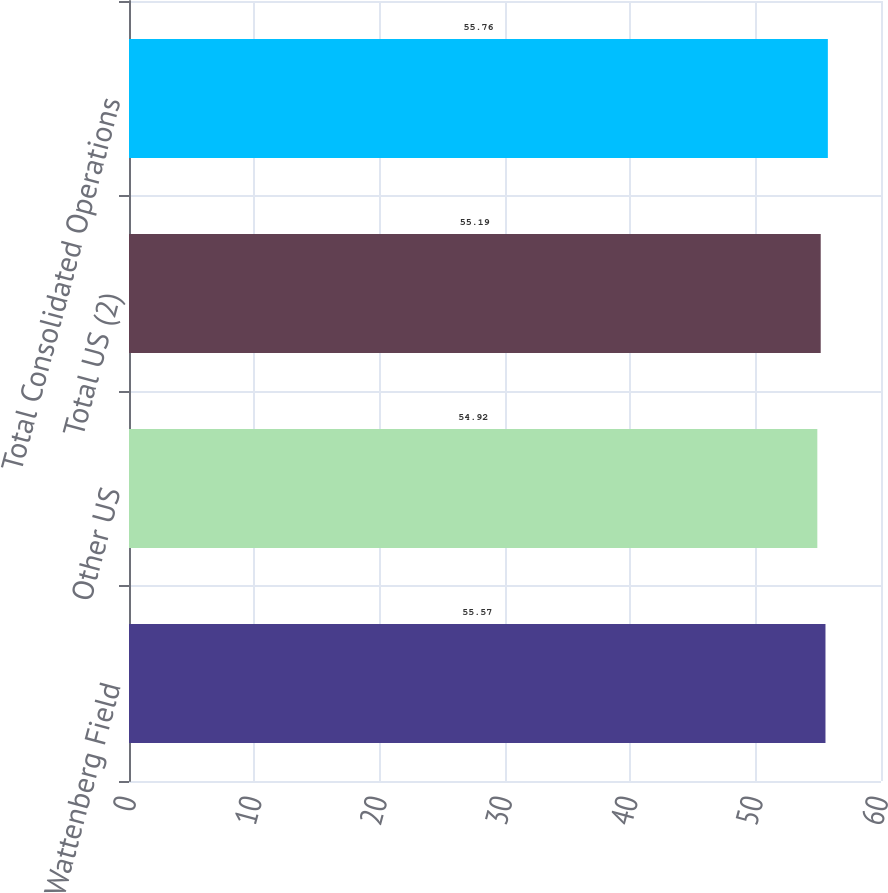Convert chart. <chart><loc_0><loc_0><loc_500><loc_500><bar_chart><fcel>Wattenberg Field<fcel>Other US<fcel>Total US (2)<fcel>Total Consolidated Operations<nl><fcel>55.57<fcel>54.92<fcel>55.19<fcel>55.76<nl></chart> 